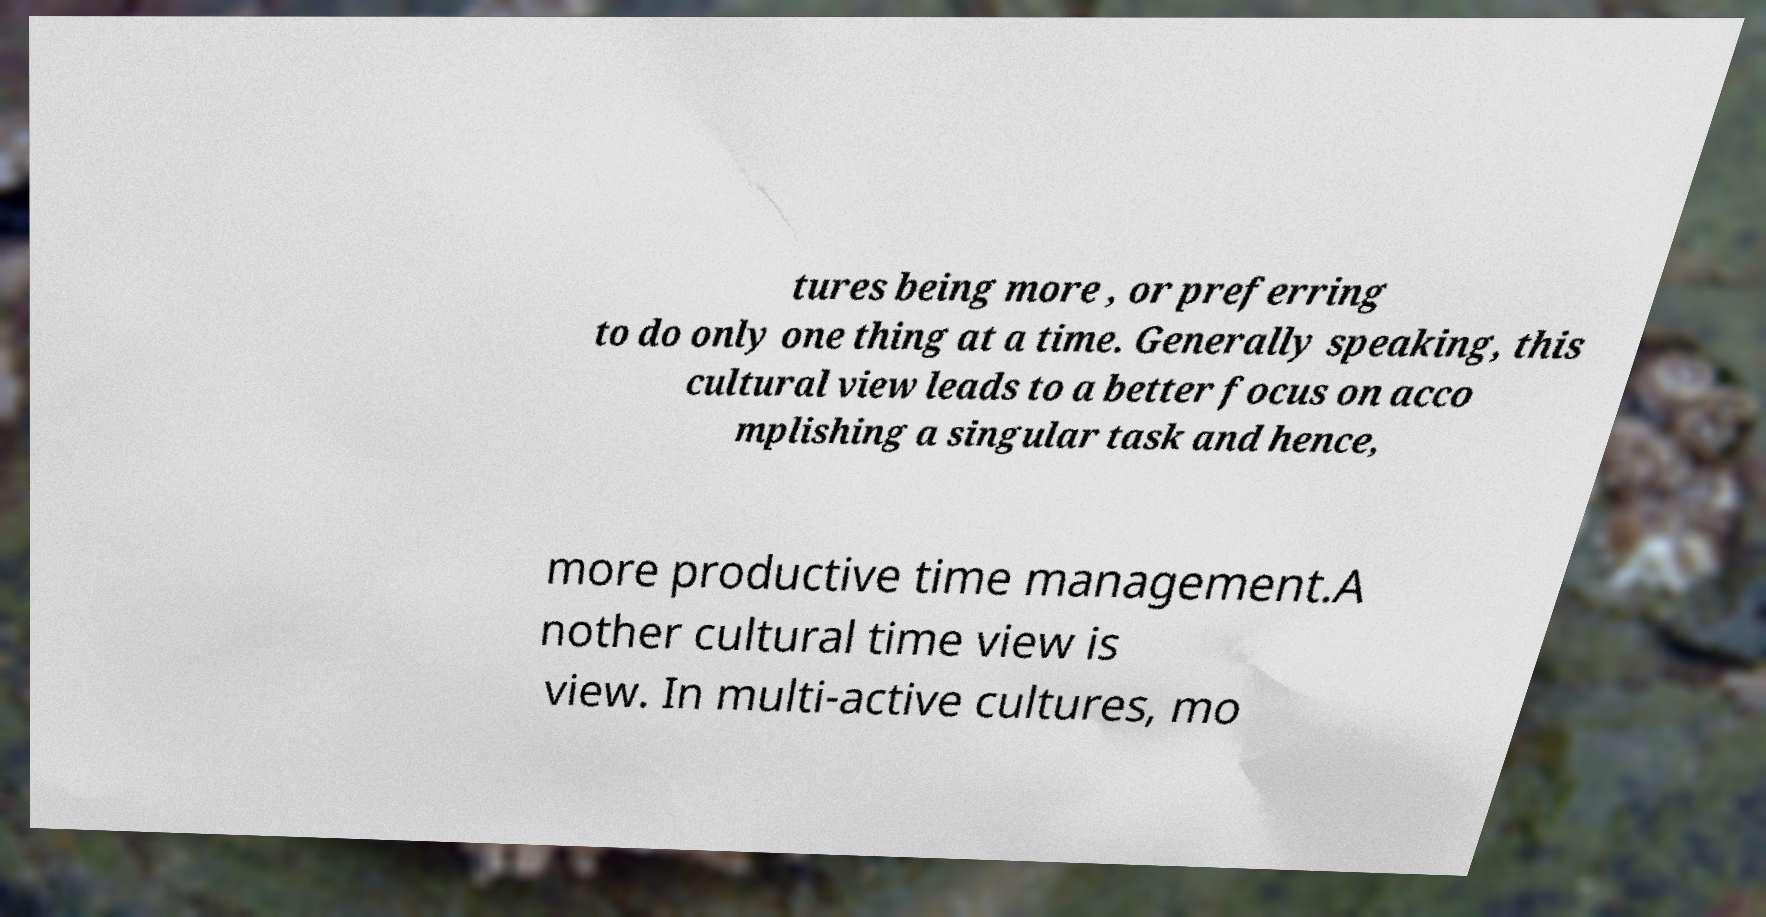Can you read and provide the text displayed in the image?This photo seems to have some interesting text. Can you extract and type it out for me? tures being more , or preferring to do only one thing at a time. Generally speaking, this cultural view leads to a better focus on acco mplishing a singular task and hence, more productive time management.A nother cultural time view is view. In multi-active cultures, mo 